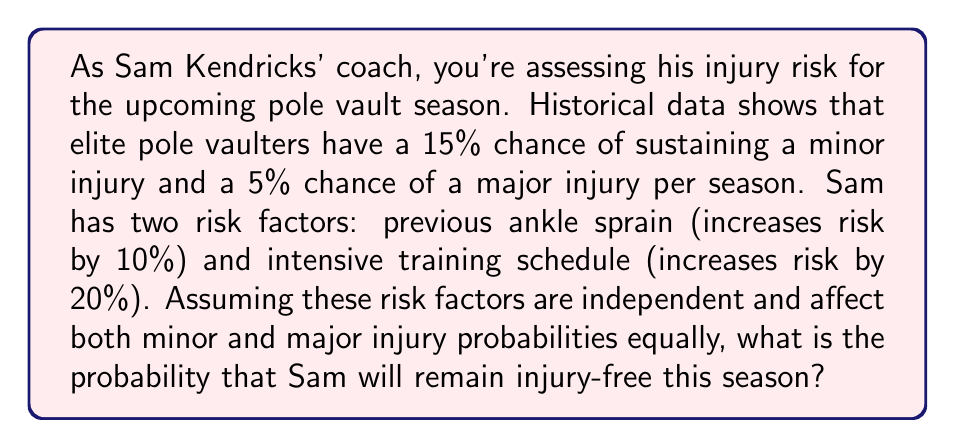Teach me how to tackle this problem. Let's approach this step-by-step:

1) First, let's calculate the base probabilities:
   P(no injury) = 1 - P(minor injury) - P(major injury)
   P(no injury) = 1 - 0.15 - 0.05 = 0.80 or 80%

2) Now, we need to account for the risk factors. Each risk factor increases the probability of injury, so it decreases the probability of remaining injury-free.

3) For the ankle sprain:
   Decrease in P(no injury) = 0.80 * 0.10 = 0.08
   New P(no injury after ankle sprain) = 0.80 - 0.08 = 0.72 or 72%

4) For the intensive training schedule:
   Decrease in P(no injury) = 0.72 * 0.20 = 0.144
   New P(no injury after both factors) = 0.72 - 0.144 = 0.576 or 57.6%

5) Therefore, the probability that Sam will remain injury-free this season is 57.6%.

6) We can also express this as an equation:

   $$P(\text{no injury}) = (1 - P(\text{minor}) - P(\text{major})) * (1 - R_1) * (1 - R_2)$$

   Where $R_1$ and $R_2$ are the risk increases from the two factors.

   $$P(\text{no injury}) = (1 - 0.15 - 0.05) * (1 - 0.10) * (1 - 0.20) = 0.576$$
Answer: 0.576 or 57.6% 